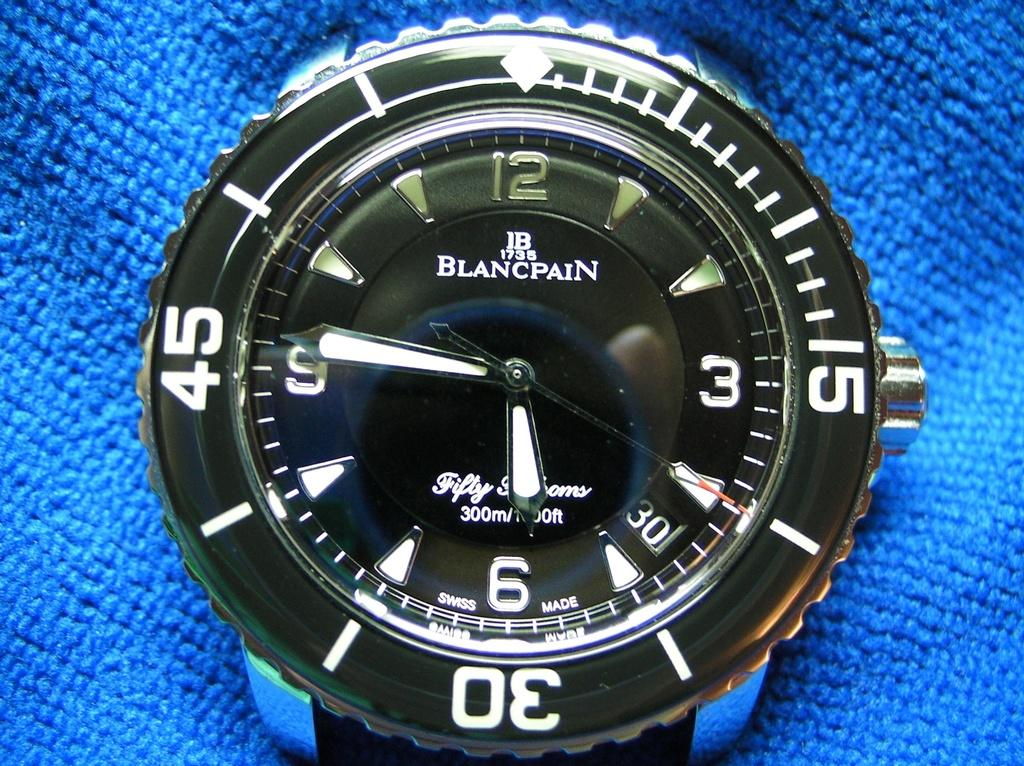Provide a one-sentence caption for the provided image. A Blancpain watch face sits on a bright blue cloth. 